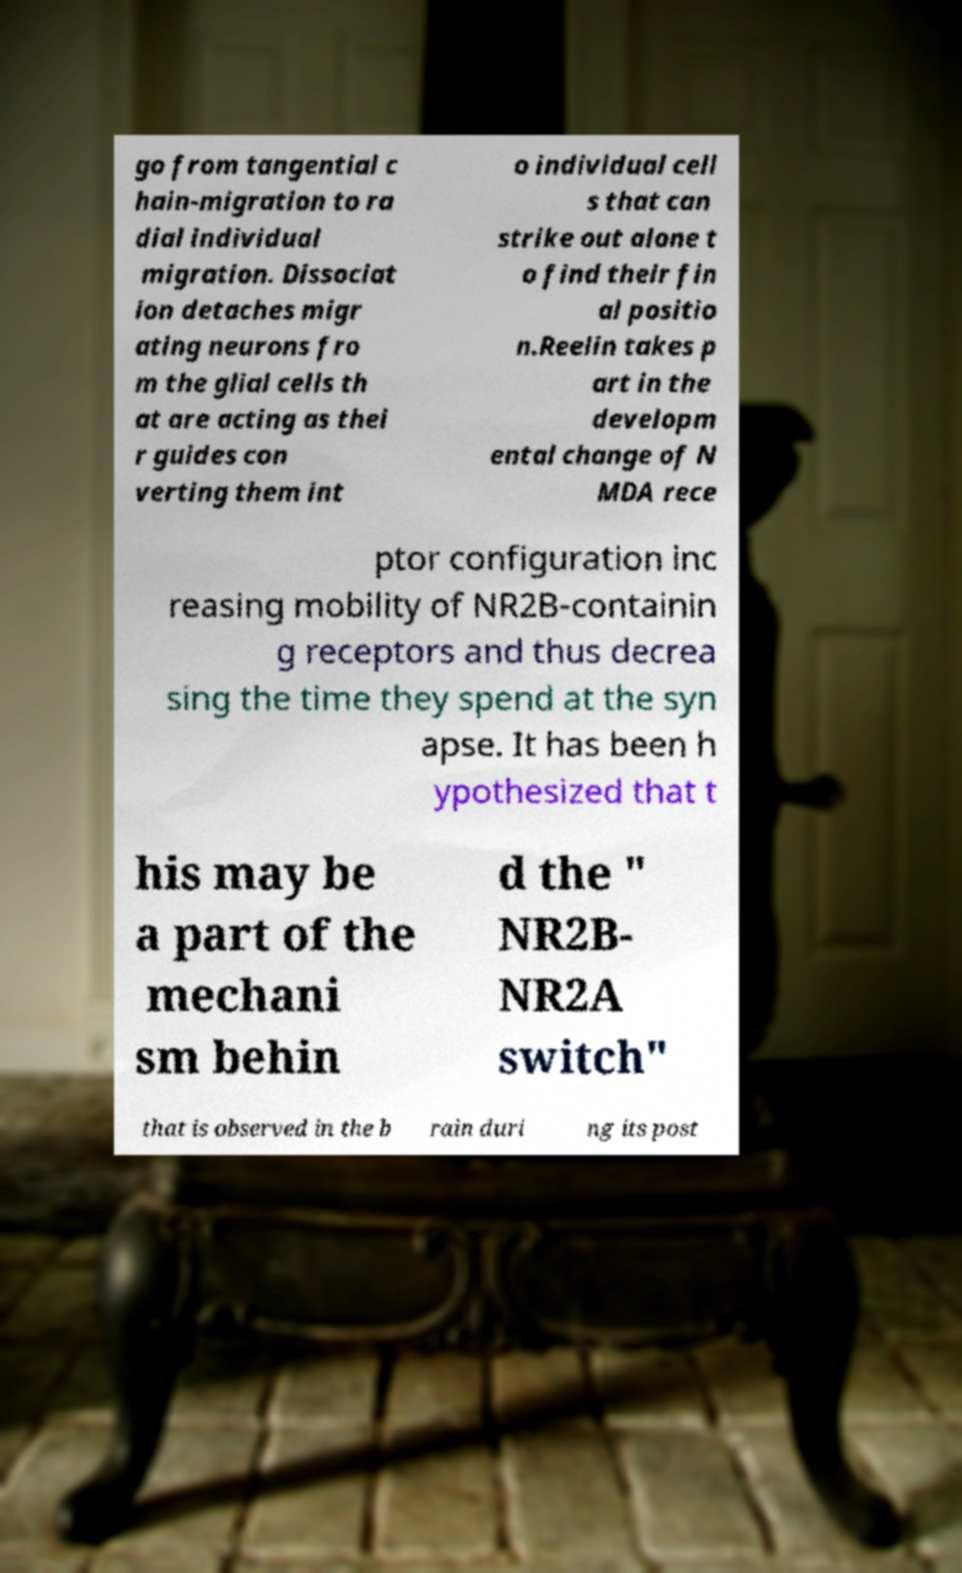Can you read and provide the text displayed in the image?This photo seems to have some interesting text. Can you extract and type it out for me? go from tangential c hain-migration to ra dial individual migration. Dissociat ion detaches migr ating neurons fro m the glial cells th at are acting as thei r guides con verting them int o individual cell s that can strike out alone t o find their fin al positio n.Reelin takes p art in the developm ental change of N MDA rece ptor configuration inc reasing mobility of NR2B-containin g receptors and thus decrea sing the time they spend at the syn apse. It has been h ypothesized that t his may be a part of the mechani sm behin d the " NR2B- NR2A switch" that is observed in the b rain duri ng its post 